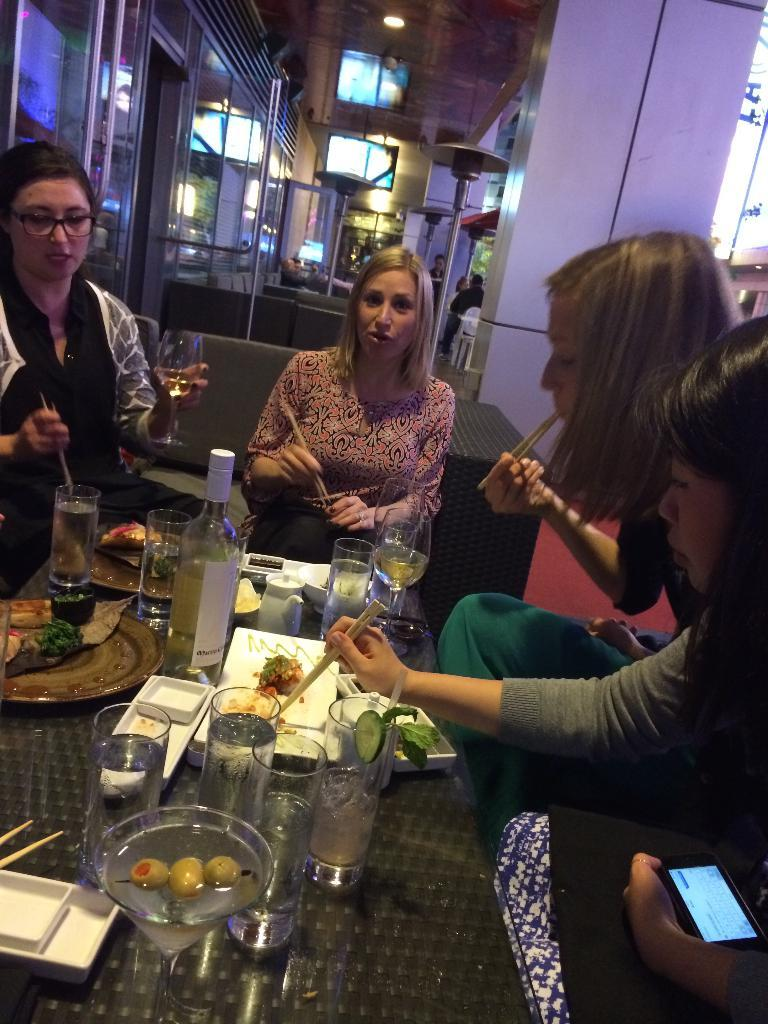What are the people in the image doing? The people in the image are sitting and eating. What can be seen on the table in the image? There is a wine glass bottle, a kettle, and food on a plate on the table. What might the people be using to drink in the image? The wine glass bottle suggests that they might be using it to drink. What business opportunity is being discussed in the image? There is no indication in the image that a business opportunity is being discussed; the people are simply eating. 